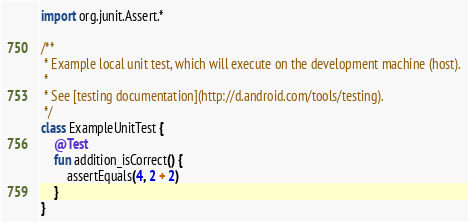Convert code to text. <code><loc_0><loc_0><loc_500><loc_500><_Kotlin_>
import org.junit.Assert.*

/**
 * Example local unit test, which will execute on the development machine (host).
 *
 * See [testing documentation](http://d.android.com/tools/testing).
 */
class ExampleUnitTest {
    @Test
    fun addition_isCorrect() {
        assertEquals(4, 2 + 2)
    }
}</code> 